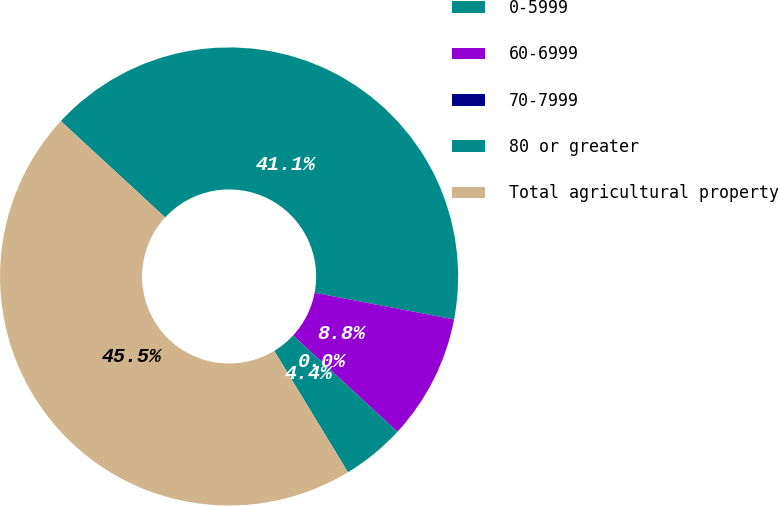<chart> <loc_0><loc_0><loc_500><loc_500><pie_chart><fcel>0-5999<fcel>60-6999<fcel>70-7999<fcel>80 or greater<fcel>Total agricultural property<nl><fcel>41.14%<fcel>8.84%<fcel>0.03%<fcel>4.44%<fcel>45.55%<nl></chart> 